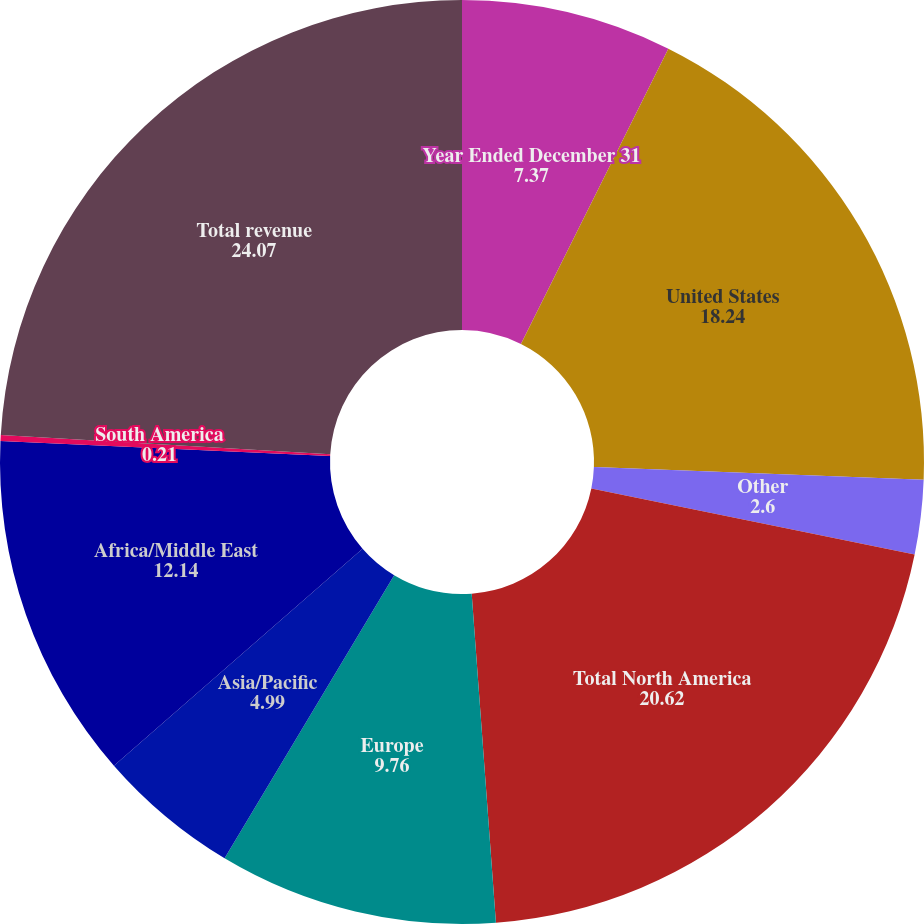Convert chart. <chart><loc_0><loc_0><loc_500><loc_500><pie_chart><fcel>Year Ended December 31<fcel>United States<fcel>Other<fcel>Total North America<fcel>Europe<fcel>Asia/Pacific<fcel>Africa/Middle East<fcel>South America<fcel>Total revenue<nl><fcel>7.37%<fcel>18.24%<fcel>2.6%<fcel>20.62%<fcel>9.76%<fcel>4.99%<fcel>12.14%<fcel>0.21%<fcel>24.07%<nl></chart> 